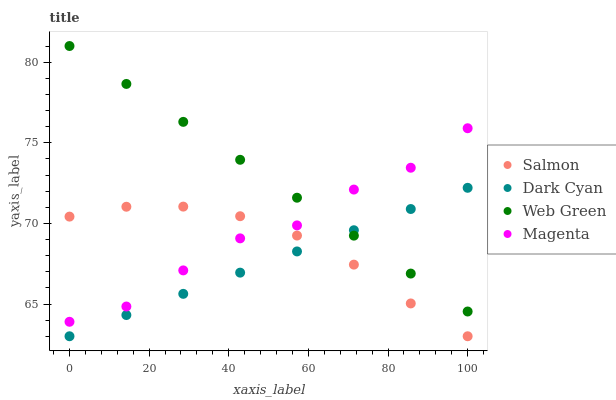Does Dark Cyan have the minimum area under the curve?
Answer yes or no. Yes. Does Web Green have the maximum area under the curve?
Answer yes or no. Yes. Does Magenta have the minimum area under the curve?
Answer yes or no. No. Does Magenta have the maximum area under the curve?
Answer yes or no. No. Is Dark Cyan the smoothest?
Answer yes or no. Yes. Is Magenta the roughest?
Answer yes or no. Yes. Is Salmon the smoothest?
Answer yes or no. No. Is Salmon the roughest?
Answer yes or no. No. Does Dark Cyan have the lowest value?
Answer yes or no. Yes. Does Magenta have the lowest value?
Answer yes or no. No. Does Web Green have the highest value?
Answer yes or no. Yes. Does Magenta have the highest value?
Answer yes or no. No. Is Salmon less than Web Green?
Answer yes or no. Yes. Is Web Green greater than Salmon?
Answer yes or no. Yes. Does Dark Cyan intersect Web Green?
Answer yes or no. Yes. Is Dark Cyan less than Web Green?
Answer yes or no. No. Is Dark Cyan greater than Web Green?
Answer yes or no. No. Does Salmon intersect Web Green?
Answer yes or no. No. 